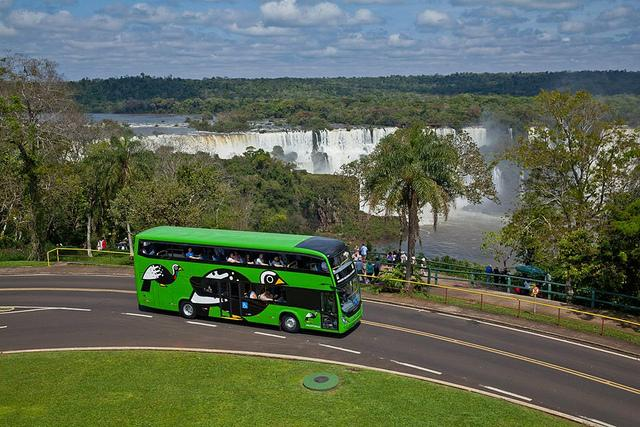Where are the people on the bus going?

Choices:
A) to school
B) home
C) to work
D) sightseeing sightseeing 